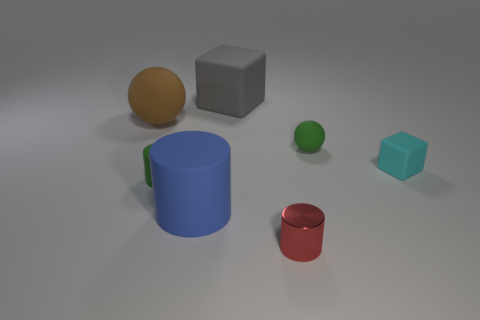There is a tiny green matte object left of the big blue object; is its shape the same as the big matte thing to the left of the large blue rubber object?
Ensure brevity in your answer.  No. What is the color of the large thing that is in front of the sphere right of the small object that is in front of the tiny green cylinder?
Your response must be concise. Blue. How many other things are the same color as the tiny sphere?
Offer a very short reply. 1. Is the number of brown spheres less than the number of brown matte cubes?
Offer a terse response. No. There is a big matte thing that is both behind the blue cylinder and on the right side of the brown rubber sphere; what is its color?
Make the answer very short. Gray. What is the material of the big blue object that is the same shape as the red thing?
Make the answer very short. Rubber. Are there more big red rubber cylinders than tiny red objects?
Your response must be concise. No. What is the size of the object that is both behind the tiny green matte ball and on the left side of the large blue cylinder?
Ensure brevity in your answer.  Large. The cyan thing has what shape?
Offer a terse response. Cube. What number of big gray rubber objects have the same shape as the cyan rubber object?
Keep it short and to the point. 1. 